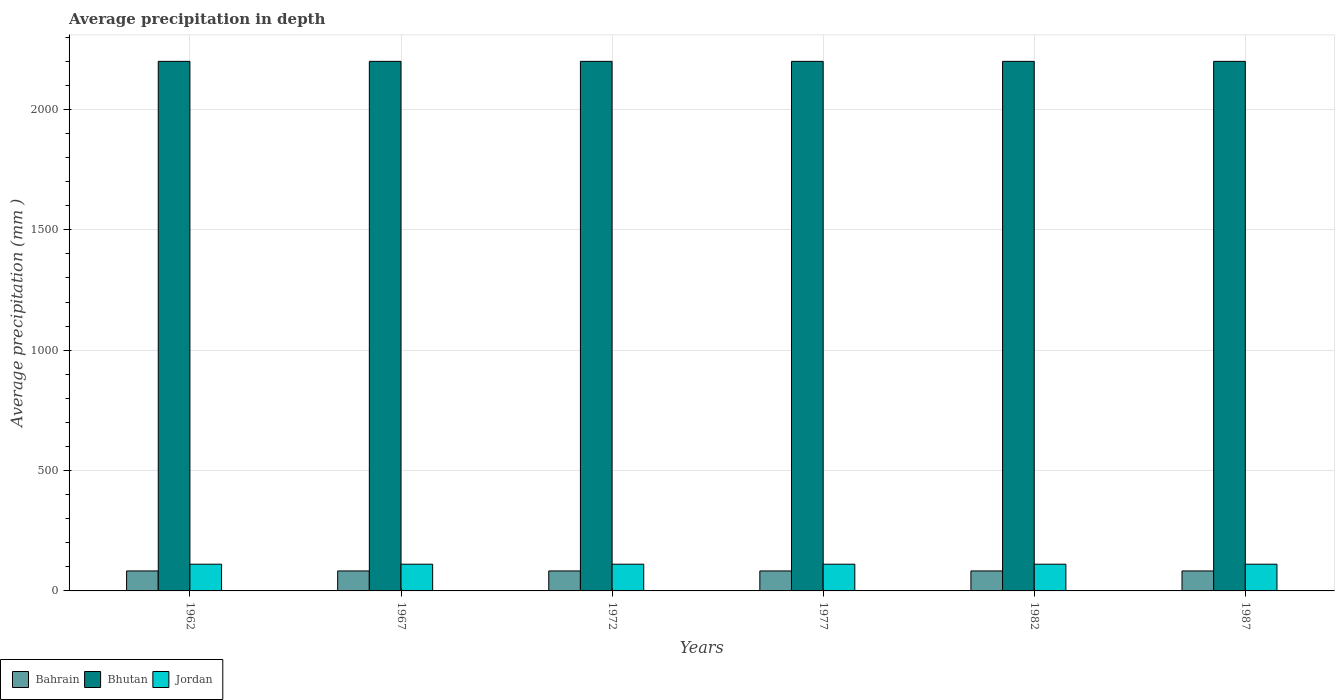Are the number of bars per tick equal to the number of legend labels?
Offer a terse response. Yes. How many bars are there on the 6th tick from the left?
Provide a short and direct response. 3. What is the label of the 4th group of bars from the left?
Give a very brief answer. 1977. In how many cases, is the number of bars for a given year not equal to the number of legend labels?
Your answer should be very brief. 0. What is the average precipitation in Bahrain in 1962?
Your response must be concise. 83. Across all years, what is the maximum average precipitation in Bahrain?
Offer a very short reply. 83. Across all years, what is the minimum average precipitation in Bahrain?
Offer a terse response. 83. In which year was the average precipitation in Bahrain minimum?
Ensure brevity in your answer.  1962. What is the total average precipitation in Bahrain in the graph?
Your answer should be very brief. 498. What is the difference between the average precipitation in Bhutan in 1962 and the average precipitation in Jordan in 1977?
Your answer should be very brief. 2089. In the year 1987, what is the difference between the average precipitation in Bhutan and average precipitation in Bahrain?
Ensure brevity in your answer.  2117. In how many years, is the average precipitation in Bahrain greater than 900 mm?
Your answer should be compact. 0. Is the difference between the average precipitation in Bhutan in 1967 and 1987 greater than the difference between the average precipitation in Bahrain in 1967 and 1987?
Offer a terse response. No. What is the difference between the highest and the second highest average precipitation in Bhutan?
Offer a terse response. 0. What is the difference between the highest and the lowest average precipitation in Bhutan?
Give a very brief answer. 0. Is the sum of the average precipitation in Bahrain in 1962 and 1987 greater than the maximum average precipitation in Bhutan across all years?
Ensure brevity in your answer.  No. What does the 2nd bar from the left in 1972 represents?
Give a very brief answer. Bhutan. What does the 2nd bar from the right in 1967 represents?
Provide a short and direct response. Bhutan. Is it the case that in every year, the sum of the average precipitation in Bahrain and average precipitation in Jordan is greater than the average precipitation in Bhutan?
Your response must be concise. No. How many bars are there?
Make the answer very short. 18. Are all the bars in the graph horizontal?
Provide a short and direct response. No. How many years are there in the graph?
Give a very brief answer. 6. What is the difference between two consecutive major ticks on the Y-axis?
Offer a terse response. 500. Are the values on the major ticks of Y-axis written in scientific E-notation?
Make the answer very short. No. Does the graph contain any zero values?
Your response must be concise. No. What is the title of the graph?
Provide a short and direct response. Average precipitation in depth. Does "South Asia" appear as one of the legend labels in the graph?
Make the answer very short. No. What is the label or title of the X-axis?
Provide a succinct answer. Years. What is the label or title of the Y-axis?
Offer a terse response. Average precipitation (mm ). What is the Average precipitation (mm ) of Bahrain in 1962?
Your answer should be very brief. 83. What is the Average precipitation (mm ) in Bhutan in 1962?
Offer a terse response. 2200. What is the Average precipitation (mm ) in Jordan in 1962?
Keep it short and to the point. 111. What is the Average precipitation (mm ) in Bahrain in 1967?
Make the answer very short. 83. What is the Average precipitation (mm ) of Bhutan in 1967?
Provide a succinct answer. 2200. What is the Average precipitation (mm ) in Jordan in 1967?
Provide a short and direct response. 111. What is the Average precipitation (mm ) in Bhutan in 1972?
Provide a succinct answer. 2200. What is the Average precipitation (mm ) in Jordan in 1972?
Your answer should be very brief. 111. What is the Average precipitation (mm ) in Bhutan in 1977?
Your answer should be compact. 2200. What is the Average precipitation (mm ) in Jordan in 1977?
Your response must be concise. 111. What is the Average precipitation (mm ) in Bhutan in 1982?
Your answer should be very brief. 2200. What is the Average precipitation (mm ) in Jordan in 1982?
Your answer should be compact. 111. What is the Average precipitation (mm ) in Bahrain in 1987?
Provide a succinct answer. 83. What is the Average precipitation (mm ) of Bhutan in 1987?
Ensure brevity in your answer.  2200. What is the Average precipitation (mm ) in Jordan in 1987?
Offer a terse response. 111. Across all years, what is the maximum Average precipitation (mm ) in Bhutan?
Offer a very short reply. 2200. Across all years, what is the maximum Average precipitation (mm ) in Jordan?
Provide a succinct answer. 111. Across all years, what is the minimum Average precipitation (mm ) in Bhutan?
Ensure brevity in your answer.  2200. Across all years, what is the minimum Average precipitation (mm ) in Jordan?
Your answer should be very brief. 111. What is the total Average precipitation (mm ) of Bahrain in the graph?
Give a very brief answer. 498. What is the total Average precipitation (mm ) in Bhutan in the graph?
Your answer should be compact. 1.32e+04. What is the total Average precipitation (mm ) of Jordan in the graph?
Give a very brief answer. 666. What is the difference between the Average precipitation (mm ) of Bahrain in 1962 and that in 1967?
Your answer should be very brief. 0. What is the difference between the Average precipitation (mm ) in Jordan in 1962 and that in 1967?
Keep it short and to the point. 0. What is the difference between the Average precipitation (mm ) of Bahrain in 1962 and that in 1972?
Ensure brevity in your answer.  0. What is the difference between the Average precipitation (mm ) in Jordan in 1962 and that in 1977?
Your answer should be very brief. 0. What is the difference between the Average precipitation (mm ) in Bhutan in 1962 and that in 1982?
Your response must be concise. 0. What is the difference between the Average precipitation (mm ) in Jordan in 1962 and that in 1982?
Offer a very short reply. 0. What is the difference between the Average precipitation (mm ) in Bahrain in 1967 and that in 1972?
Keep it short and to the point. 0. What is the difference between the Average precipitation (mm ) of Bhutan in 1967 and that in 1972?
Your response must be concise. 0. What is the difference between the Average precipitation (mm ) in Bahrain in 1967 and that in 1977?
Provide a succinct answer. 0. What is the difference between the Average precipitation (mm ) in Bhutan in 1967 and that in 1987?
Give a very brief answer. 0. What is the difference between the Average precipitation (mm ) of Bahrain in 1972 and that in 1977?
Provide a short and direct response. 0. What is the difference between the Average precipitation (mm ) in Jordan in 1972 and that in 1977?
Keep it short and to the point. 0. What is the difference between the Average precipitation (mm ) in Bahrain in 1972 and that in 1982?
Make the answer very short. 0. What is the difference between the Average precipitation (mm ) in Jordan in 1972 and that in 1982?
Your answer should be compact. 0. What is the difference between the Average precipitation (mm ) of Bhutan in 1972 and that in 1987?
Offer a very short reply. 0. What is the difference between the Average precipitation (mm ) of Bahrain in 1977 and that in 1982?
Your answer should be very brief. 0. What is the difference between the Average precipitation (mm ) in Bhutan in 1977 and that in 1982?
Offer a very short reply. 0. What is the difference between the Average precipitation (mm ) of Bahrain in 1982 and that in 1987?
Your answer should be very brief. 0. What is the difference between the Average precipitation (mm ) in Bhutan in 1982 and that in 1987?
Offer a terse response. 0. What is the difference between the Average precipitation (mm ) of Jordan in 1982 and that in 1987?
Provide a short and direct response. 0. What is the difference between the Average precipitation (mm ) in Bahrain in 1962 and the Average precipitation (mm ) in Bhutan in 1967?
Keep it short and to the point. -2117. What is the difference between the Average precipitation (mm ) of Bhutan in 1962 and the Average precipitation (mm ) of Jordan in 1967?
Keep it short and to the point. 2089. What is the difference between the Average precipitation (mm ) in Bahrain in 1962 and the Average precipitation (mm ) in Bhutan in 1972?
Your answer should be compact. -2117. What is the difference between the Average precipitation (mm ) in Bhutan in 1962 and the Average precipitation (mm ) in Jordan in 1972?
Give a very brief answer. 2089. What is the difference between the Average precipitation (mm ) of Bahrain in 1962 and the Average precipitation (mm ) of Bhutan in 1977?
Your answer should be very brief. -2117. What is the difference between the Average precipitation (mm ) in Bahrain in 1962 and the Average precipitation (mm ) in Jordan in 1977?
Your answer should be compact. -28. What is the difference between the Average precipitation (mm ) in Bhutan in 1962 and the Average precipitation (mm ) in Jordan in 1977?
Ensure brevity in your answer.  2089. What is the difference between the Average precipitation (mm ) in Bahrain in 1962 and the Average precipitation (mm ) in Bhutan in 1982?
Keep it short and to the point. -2117. What is the difference between the Average precipitation (mm ) in Bahrain in 1962 and the Average precipitation (mm ) in Jordan in 1982?
Your answer should be very brief. -28. What is the difference between the Average precipitation (mm ) of Bhutan in 1962 and the Average precipitation (mm ) of Jordan in 1982?
Make the answer very short. 2089. What is the difference between the Average precipitation (mm ) of Bahrain in 1962 and the Average precipitation (mm ) of Bhutan in 1987?
Make the answer very short. -2117. What is the difference between the Average precipitation (mm ) of Bhutan in 1962 and the Average precipitation (mm ) of Jordan in 1987?
Offer a terse response. 2089. What is the difference between the Average precipitation (mm ) in Bahrain in 1967 and the Average precipitation (mm ) in Bhutan in 1972?
Your response must be concise. -2117. What is the difference between the Average precipitation (mm ) in Bhutan in 1967 and the Average precipitation (mm ) in Jordan in 1972?
Offer a very short reply. 2089. What is the difference between the Average precipitation (mm ) in Bahrain in 1967 and the Average precipitation (mm ) in Bhutan in 1977?
Keep it short and to the point. -2117. What is the difference between the Average precipitation (mm ) of Bhutan in 1967 and the Average precipitation (mm ) of Jordan in 1977?
Give a very brief answer. 2089. What is the difference between the Average precipitation (mm ) of Bahrain in 1967 and the Average precipitation (mm ) of Bhutan in 1982?
Offer a terse response. -2117. What is the difference between the Average precipitation (mm ) of Bhutan in 1967 and the Average precipitation (mm ) of Jordan in 1982?
Provide a succinct answer. 2089. What is the difference between the Average precipitation (mm ) of Bahrain in 1967 and the Average precipitation (mm ) of Bhutan in 1987?
Provide a succinct answer. -2117. What is the difference between the Average precipitation (mm ) of Bhutan in 1967 and the Average precipitation (mm ) of Jordan in 1987?
Keep it short and to the point. 2089. What is the difference between the Average precipitation (mm ) of Bahrain in 1972 and the Average precipitation (mm ) of Bhutan in 1977?
Offer a terse response. -2117. What is the difference between the Average precipitation (mm ) in Bahrain in 1972 and the Average precipitation (mm ) in Jordan in 1977?
Offer a very short reply. -28. What is the difference between the Average precipitation (mm ) of Bhutan in 1972 and the Average precipitation (mm ) of Jordan in 1977?
Make the answer very short. 2089. What is the difference between the Average precipitation (mm ) in Bahrain in 1972 and the Average precipitation (mm ) in Bhutan in 1982?
Offer a very short reply. -2117. What is the difference between the Average precipitation (mm ) of Bahrain in 1972 and the Average precipitation (mm ) of Jordan in 1982?
Provide a short and direct response. -28. What is the difference between the Average precipitation (mm ) in Bhutan in 1972 and the Average precipitation (mm ) in Jordan in 1982?
Offer a very short reply. 2089. What is the difference between the Average precipitation (mm ) of Bahrain in 1972 and the Average precipitation (mm ) of Bhutan in 1987?
Make the answer very short. -2117. What is the difference between the Average precipitation (mm ) in Bhutan in 1972 and the Average precipitation (mm ) in Jordan in 1987?
Offer a terse response. 2089. What is the difference between the Average precipitation (mm ) in Bahrain in 1977 and the Average precipitation (mm ) in Bhutan in 1982?
Offer a terse response. -2117. What is the difference between the Average precipitation (mm ) of Bhutan in 1977 and the Average precipitation (mm ) of Jordan in 1982?
Ensure brevity in your answer.  2089. What is the difference between the Average precipitation (mm ) in Bahrain in 1977 and the Average precipitation (mm ) in Bhutan in 1987?
Offer a terse response. -2117. What is the difference between the Average precipitation (mm ) in Bhutan in 1977 and the Average precipitation (mm ) in Jordan in 1987?
Offer a terse response. 2089. What is the difference between the Average precipitation (mm ) in Bahrain in 1982 and the Average precipitation (mm ) in Bhutan in 1987?
Provide a succinct answer. -2117. What is the difference between the Average precipitation (mm ) in Bahrain in 1982 and the Average precipitation (mm ) in Jordan in 1987?
Keep it short and to the point. -28. What is the difference between the Average precipitation (mm ) in Bhutan in 1982 and the Average precipitation (mm ) in Jordan in 1987?
Give a very brief answer. 2089. What is the average Average precipitation (mm ) of Bahrain per year?
Offer a very short reply. 83. What is the average Average precipitation (mm ) of Bhutan per year?
Provide a short and direct response. 2200. What is the average Average precipitation (mm ) of Jordan per year?
Keep it short and to the point. 111. In the year 1962, what is the difference between the Average precipitation (mm ) of Bahrain and Average precipitation (mm ) of Bhutan?
Keep it short and to the point. -2117. In the year 1962, what is the difference between the Average precipitation (mm ) of Bahrain and Average precipitation (mm ) of Jordan?
Keep it short and to the point. -28. In the year 1962, what is the difference between the Average precipitation (mm ) in Bhutan and Average precipitation (mm ) in Jordan?
Your answer should be compact. 2089. In the year 1967, what is the difference between the Average precipitation (mm ) of Bahrain and Average precipitation (mm ) of Bhutan?
Provide a succinct answer. -2117. In the year 1967, what is the difference between the Average precipitation (mm ) in Bhutan and Average precipitation (mm ) in Jordan?
Offer a very short reply. 2089. In the year 1972, what is the difference between the Average precipitation (mm ) of Bahrain and Average precipitation (mm ) of Bhutan?
Give a very brief answer. -2117. In the year 1972, what is the difference between the Average precipitation (mm ) in Bahrain and Average precipitation (mm ) in Jordan?
Offer a very short reply. -28. In the year 1972, what is the difference between the Average precipitation (mm ) in Bhutan and Average precipitation (mm ) in Jordan?
Provide a succinct answer. 2089. In the year 1977, what is the difference between the Average precipitation (mm ) of Bahrain and Average precipitation (mm ) of Bhutan?
Your answer should be very brief. -2117. In the year 1977, what is the difference between the Average precipitation (mm ) in Bhutan and Average precipitation (mm ) in Jordan?
Make the answer very short. 2089. In the year 1982, what is the difference between the Average precipitation (mm ) in Bahrain and Average precipitation (mm ) in Bhutan?
Offer a very short reply. -2117. In the year 1982, what is the difference between the Average precipitation (mm ) of Bhutan and Average precipitation (mm ) of Jordan?
Give a very brief answer. 2089. In the year 1987, what is the difference between the Average precipitation (mm ) in Bahrain and Average precipitation (mm ) in Bhutan?
Your response must be concise. -2117. In the year 1987, what is the difference between the Average precipitation (mm ) in Bhutan and Average precipitation (mm ) in Jordan?
Give a very brief answer. 2089. What is the ratio of the Average precipitation (mm ) in Jordan in 1962 to that in 1967?
Offer a terse response. 1. What is the ratio of the Average precipitation (mm ) of Jordan in 1962 to that in 1972?
Offer a terse response. 1. What is the ratio of the Average precipitation (mm ) of Jordan in 1962 to that in 1977?
Give a very brief answer. 1. What is the ratio of the Average precipitation (mm ) of Bhutan in 1962 to that in 1982?
Your answer should be very brief. 1. What is the ratio of the Average precipitation (mm ) of Jordan in 1962 to that in 1987?
Offer a terse response. 1. What is the ratio of the Average precipitation (mm ) in Bhutan in 1967 to that in 1972?
Keep it short and to the point. 1. What is the ratio of the Average precipitation (mm ) in Bahrain in 1967 to that in 1977?
Provide a succinct answer. 1. What is the ratio of the Average precipitation (mm ) of Bhutan in 1967 to that in 1977?
Provide a succinct answer. 1. What is the ratio of the Average precipitation (mm ) of Bahrain in 1967 to that in 1982?
Offer a very short reply. 1. What is the ratio of the Average precipitation (mm ) in Bhutan in 1967 to that in 1982?
Your answer should be very brief. 1. What is the ratio of the Average precipitation (mm ) in Jordan in 1967 to that in 1982?
Your response must be concise. 1. What is the ratio of the Average precipitation (mm ) of Bhutan in 1967 to that in 1987?
Keep it short and to the point. 1. What is the ratio of the Average precipitation (mm ) in Jordan in 1967 to that in 1987?
Your response must be concise. 1. What is the ratio of the Average precipitation (mm ) in Bahrain in 1972 to that in 1982?
Your answer should be very brief. 1. What is the ratio of the Average precipitation (mm ) of Bhutan in 1972 to that in 1987?
Offer a very short reply. 1. What is the ratio of the Average precipitation (mm ) of Bhutan in 1977 to that in 1982?
Offer a very short reply. 1. What is the ratio of the Average precipitation (mm ) of Jordan in 1977 to that in 1982?
Provide a short and direct response. 1. What is the ratio of the Average precipitation (mm ) of Bahrain in 1977 to that in 1987?
Your response must be concise. 1. What is the ratio of the Average precipitation (mm ) of Bhutan in 1977 to that in 1987?
Your answer should be very brief. 1. What is the ratio of the Average precipitation (mm ) of Bahrain in 1982 to that in 1987?
Ensure brevity in your answer.  1. What is the ratio of the Average precipitation (mm ) in Bhutan in 1982 to that in 1987?
Keep it short and to the point. 1. What is the ratio of the Average precipitation (mm ) in Jordan in 1982 to that in 1987?
Provide a short and direct response. 1. What is the difference between the highest and the lowest Average precipitation (mm ) of Bhutan?
Your answer should be compact. 0. 